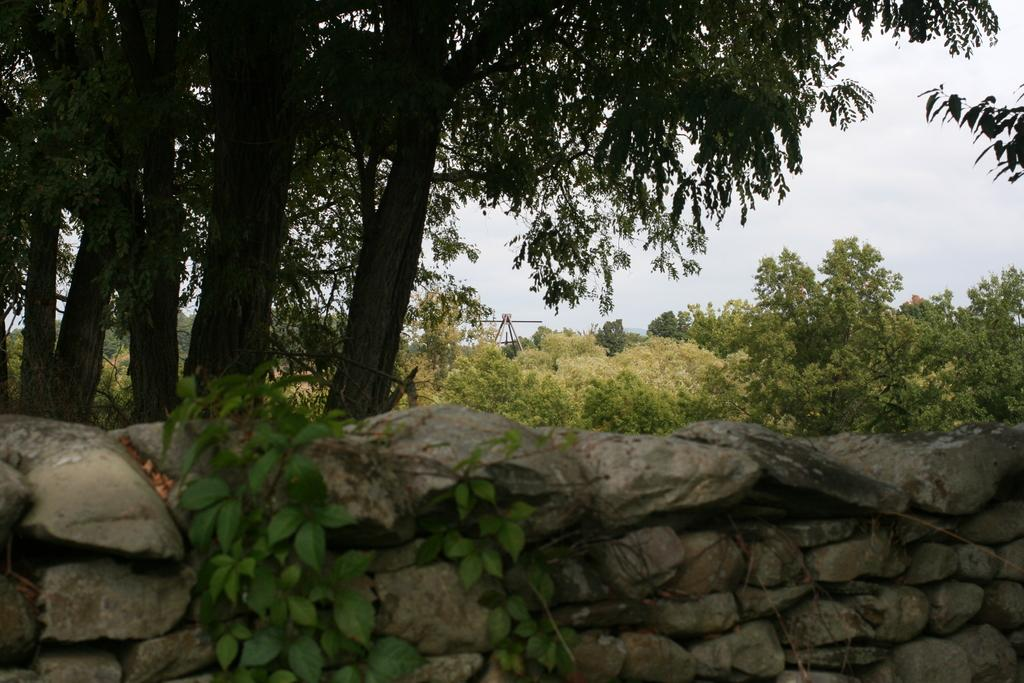What can be seen in the foreground of the image? There are plants and a stone wall in the foreground of the image. What is visible in the background of the image? There is a group of trees, metal poles, and the sky visible in the background of the image. What type of whip can be seen hanging from the metal poles in the image? There is no whip present in the image; it features plants, a stone wall, trees, metal poles, and the sky. 